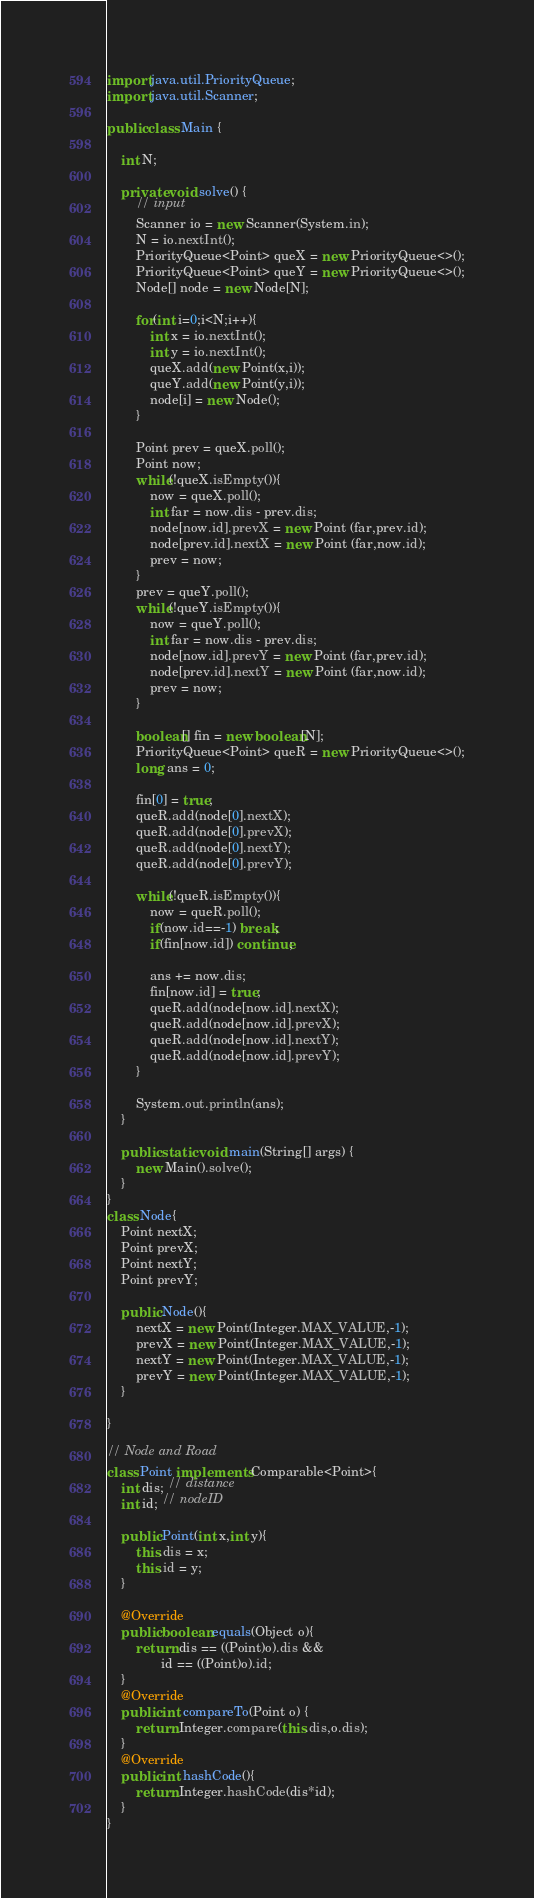Convert code to text. <code><loc_0><loc_0><loc_500><loc_500><_Java_>import java.util.PriorityQueue;
import java.util.Scanner;

public class Main {

	int N;

	private void solve() {
		// input
		Scanner io = new Scanner(System.in);
		N = io.nextInt();
		PriorityQueue<Point> queX = new PriorityQueue<>();
		PriorityQueue<Point> queY = new PriorityQueue<>();
		Node[] node = new Node[N];
		
		for(int i=0;i<N;i++){
			int x = io.nextInt();
			int y = io.nextInt();
			queX.add(new Point(x,i));
			queY.add(new Point(y,i));
			node[i] = new Node();
		}
		
		Point prev = queX.poll();
		Point now;
		while(!queX.isEmpty()){
			now = queX.poll();
			int far = now.dis - prev.dis;
			node[now.id].prevX = new Point (far,prev.id);
			node[prev.id].nextX = new Point (far,now.id);
			prev = now;
		}
		prev = queY.poll();
		while(!queY.isEmpty()){
			now = queY.poll();
			int far = now.dis - prev.dis;
			node[now.id].prevY = new Point (far,prev.id);
			node[prev.id].nextY = new Point (far,now.id);
			prev = now;
		}
		
		boolean[] fin = new boolean[N];
 		PriorityQueue<Point> queR = new PriorityQueue<>();
 		long ans = 0;
 		
 		fin[0] = true;
 		queR.add(node[0].nextX);
 		queR.add(node[0].prevX);
 		queR.add(node[0].nextY);
 		queR.add(node[0].prevY);
 		
 		while(!queR.isEmpty()){
 			now = queR.poll();
 			if(now.id==-1) break;
 			if(fin[now.id]) continue;
 			
 			ans += now.dis;
 			fin[now.id] = true;
 	 		queR.add(node[now.id].nextX);
 	 		queR.add(node[now.id].prevX);
 	 		queR.add(node[now.id].nextY);
 	 		queR.add(node[now.id].prevY);
  		}

		System.out.println(ans);
	}

	public static void main(String[] args) {
		new Main().solve();
	}
}
class Node{
	Point nextX;
	Point prevX;
	Point nextY;
	Point prevY;
	
	public Node(){
		nextX = new Point(Integer.MAX_VALUE,-1);
		prevX = new Point(Integer.MAX_VALUE,-1);
		nextY = new Point(Integer.MAX_VALUE,-1);
		prevY = new Point(Integer.MAX_VALUE,-1);
	}
	
}

// Node and Road
class Point implements Comparable<Point>{
	int dis; // distance
	int id; // nodeID
	
	public Point(int x,int y){
		this.dis = x;
		this.id = y;
	}

	@Override
	public boolean equals(Object o){
		return dis == ((Point)o).dis &&
			   id == ((Point)o).id;
	}
	@Override
	public int compareTo(Point o) {
		return Integer.compare(this.dis,o.dis);
	}
	@Override
	public int hashCode(){
		return Integer.hashCode(dis*id);
	}
}</code> 